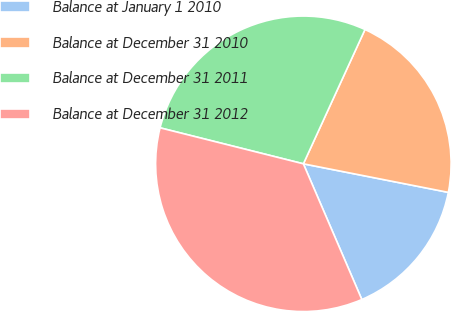<chart> <loc_0><loc_0><loc_500><loc_500><pie_chart><fcel>Balance at January 1 2010<fcel>Balance at December 31 2010<fcel>Balance at December 31 2011<fcel>Balance at December 31 2012<nl><fcel>15.43%<fcel>21.25%<fcel>27.93%<fcel>35.39%<nl></chart> 